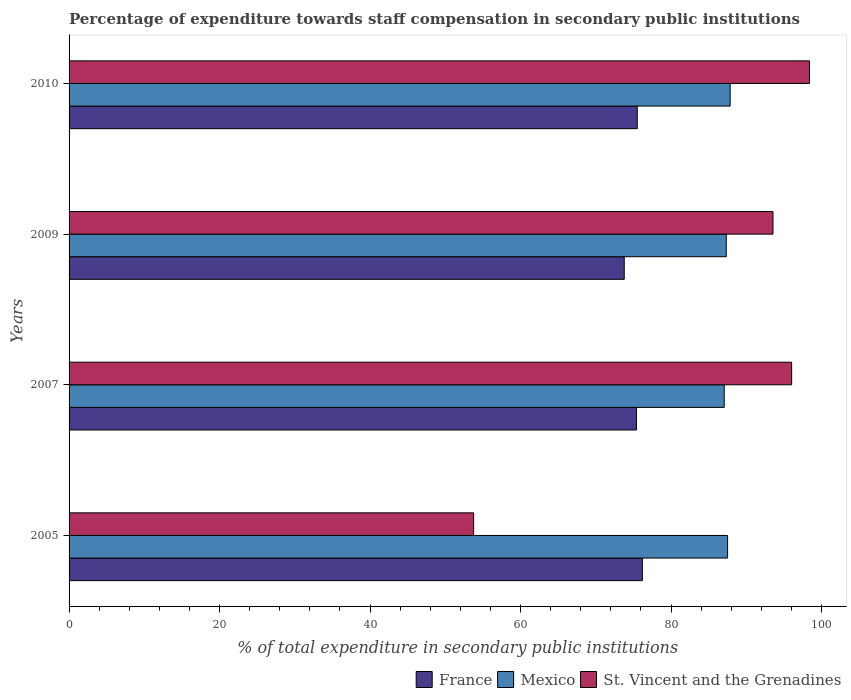How many different coloured bars are there?
Your response must be concise. 3. Are the number of bars per tick equal to the number of legend labels?
Offer a terse response. Yes. How many bars are there on the 1st tick from the top?
Make the answer very short. 3. What is the percentage of expenditure towards staff compensation in France in 2010?
Your answer should be compact. 75.51. Across all years, what is the maximum percentage of expenditure towards staff compensation in St. Vincent and the Grenadines?
Offer a terse response. 98.4. Across all years, what is the minimum percentage of expenditure towards staff compensation in France?
Your answer should be very brief. 73.78. In which year was the percentage of expenditure towards staff compensation in Mexico maximum?
Your response must be concise. 2010. In which year was the percentage of expenditure towards staff compensation in St. Vincent and the Grenadines minimum?
Offer a terse response. 2005. What is the total percentage of expenditure towards staff compensation in Mexico in the graph?
Your answer should be compact. 349.77. What is the difference between the percentage of expenditure towards staff compensation in St. Vincent and the Grenadines in 2009 and that in 2010?
Your answer should be compact. -4.85. What is the difference between the percentage of expenditure towards staff compensation in Mexico in 2009 and the percentage of expenditure towards staff compensation in France in 2007?
Offer a very short reply. 11.93. What is the average percentage of expenditure towards staff compensation in France per year?
Offer a very short reply. 75.22. In the year 2009, what is the difference between the percentage of expenditure towards staff compensation in St. Vincent and the Grenadines and percentage of expenditure towards staff compensation in France?
Your response must be concise. 19.77. In how many years, is the percentage of expenditure towards staff compensation in France greater than 44 %?
Offer a very short reply. 4. What is the ratio of the percentage of expenditure towards staff compensation in France in 2005 to that in 2010?
Make the answer very short. 1.01. Is the percentage of expenditure towards staff compensation in Mexico in 2007 less than that in 2009?
Your answer should be compact. Yes. Is the difference between the percentage of expenditure towards staff compensation in St. Vincent and the Grenadines in 2009 and 2010 greater than the difference between the percentage of expenditure towards staff compensation in France in 2009 and 2010?
Keep it short and to the point. No. What is the difference between the highest and the second highest percentage of expenditure towards staff compensation in France?
Provide a short and direct response. 0.68. What is the difference between the highest and the lowest percentage of expenditure towards staff compensation in France?
Ensure brevity in your answer.  2.41. In how many years, is the percentage of expenditure towards staff compensation in St. Vincent and the Grenadines greater than the average percentage of expenditure towards staff compensation in St. Vincent and the Grenadines taken over all years?
Provide a short and direct response. 3. Is the sum of the percentage of expenditure towards staff compensation in Mexico in 2007 and 2009 greater than the maximum percentage of expenditure towards staff compensation in France across all years?
Offer a terse response. Yes. What does the 2nd bar from the top in 2007 represents?
Make the answer very short. Mexico. What does the 3rd bar from the bottom in 2009 represents?
Make the answer very short. St. Vincent and the Grenadines. Is it the case that in every year, the sum of the percentage of expenditure towards staff compensation in Mexico and percentage of expenditure towards staff compensation in St. Vincent and the Grenadines is greater than the percentage of expenditure towards staff compensation in France?
Keep it short and to the point. Yes. How many years are there in the graph?
Your answer should be compact. 4. What is the difference between two consecutive major ticks on the X-axis?
Offer a terse response. 20. Does the graph contain any zero values?
Ensure brevity in your answer.  No. Does the graph contain grids?
Your answer should be compact. No. Where does the legend appear in the graph?
Your answer should be compact. Bottom right. How are the legend labels stacked?
Your response must be concise. Horizontal. What is the title of the graph?
Keep it short and to the point. Percentage of expenditure towards staff compensation in secondary public institutions. Does "World" appear as one of the legend labels in the graph?
Your answer should be compact. No. What is the label or title of the X-axis?
Your answer should be very brief. % of total expenditure in secondary public institutions. What is the label or title of the Y-axis?
Keep it short and to the point. Years. What is the % of total expenditure in secondary public institutions of France in 2005?
Offer a very short reply. 76.19. What is the % of total expenditure in secondary public institutions of Mexico in 2005?
Provide a short and direct response. 87.52. What is the % of total expenditure in secondary public institutions in St. Vincent and the Grenadines in 2005?
Make the answer very short. 53.76. What is the % of total expenditure in secondary public institutions of France in 2007?
Make the answer very short. 75.4. What is the % of total expenditure in secondary public institutions in Mexico in 2007?
Your answer should be compact. 87.07. What is the % of total expenditure in secondary public institutions in St. Vincent and the Grenadines in 2007?
Your answer should be compact. 96.03. What is the % of total expenditure in secondary public institutions in France in 2009?
Offer a very short reply. 73.78. What is the % of total expenditure in secondary public institutions of Mexico in 2009?
Provide a succinct answer. 87.34. What is the % of total expenditure in secondary public institutions of St. Vincent and the Grenadines in 2009?
Ensure brevity in your answer.  93.55. What is the % of total expenditure in secondary public institutions of France in 2010?
Offer a very short reply. 75.51. What is the % of total expenditure in secondary public institutions of Mexico in 2010?
Give a very brief answer. 87.85. What is the % of total expenditure in secondary public institutions in St. Vincent and the Grenadines in 2010?
Provide a succinct answer. 98.4. Across all years, what is the maximum % of total expenditure in secondary public institutions of France?
Ensure brevity in your answer.  76.19. Across all years, what is the maximum % of total expenditure in secondary public institutions of Mexico?
Make the answer very short. 87.85. Across all years, what is the maximum % of total expenditure in secondary public institutions in St. Vincent and the Grenadines?
Ensure brevity in your answer.  98.4. Across all years, what is the minimum % of total expenditure in secondary public institutions of France?
Ensure brevity in your answer.  73.78. Across all years, what is the minimum % of total expenditure in secondary public institutions of Mexico?
Provide a succinct answer. 87.07. Across all years, what is the minimum % of total expenditure in secondary public institutions in St. Vincent and the Grenadines?
Provide a short and direct response. 53.76. What is the total % of total expenditure in secondary public institutions of France in the graph?
Ensure brevity in your answer.  300.88. What is the total % of total expenditure in secondary public institutions in Mexico in the graph?
Offer a terse response. 349.77. What is the total % of total expenditure in secondary public institutions of St. Vincent and the Grenadines in the graph?
Your answer should be very brief. 341.74. What is the difference between the % of total expenditure in secondary public institutions of France in 2005 and that in 2007?
Your answer should be very brief. 0.78. What is the difference between the % of total expenditure in secondary public institutions in Mexico in 2005 and that in 2007?
Provide a short and direct response. 0.45. What is the difference between the % of total expenditure in secondary public institutions in St. Vincent and the Grenadines in 2005 and that in 2007?
Provide a succinct answer. -42.26. What is the difference between the % of total expenditure in secondary public institutions in France in 2005 and that in 2009?
Keep it short and to the point. 2.41. What is the difference between the % of total expenditure in secondary public institutions in Mexico in 2005 and that in 2009?
Provide a succinct answer. 0.18. What is the difference between the % of total expenditure in secondary public institutions in St. Vincent and the Grenadines in 2005 and that in 2009?
Provide a short and direct response. -39.78. What is the difference between the % of total expenditure in secondary public institutions of France in 2005 and that in 2010?
Your answer should be compact. 0.68. What is the difference between the % of total expenditure in secondary public institutions in Mexico in 2005 and that in 2010?
Keep it short and to the point. -0.34. What is the difference between the % of total expenditure in secondary public institutions of St. Vincent and the Grenadines in 2005 and that in 2010?
Offer a very short reply. -44.63. What is the difference between the % of total expenditure in secondary public institutions in France in 2007 and that in 2009?
Provide a succinct answer. 1.63. What is the difference between the % of total expenditure in secondary public institutions of Mexico in 2007 and that in 2009?
Provide a succinct answer. -0.27. What is the difference between the % of total expenditure in secondary public institutions of St. Vincent and the Grenadines in 2007 and that in 2009?
Your answer should be compact. 2.48. What is the difference between the % of total expenditure in secondary public institutions in France in 2007 and that in 2010?
Provide a succinct answer. -0.11. What is the difference between the % of total expenditure in secondary public institutions of Mexico in 2007 and that in 2010?
Keep it short and to the point. -0.79. What is the difference between the % of total expenditure in secondary public institutions of St. Vincent and the Grenadines in 2007 and that in 2010?
Make the answer very short. -2.37. What is the difference between the % of total expenditure in secondary public institutions in France in 2009 and that in 2010?
Give a very brief answer. -1.73. What is the difference between the % of total expenditure in secondary public institutions of Mexico in 2009 and that in 2010?
Make the answer very short. -0.52. What is the difference between the % of total expenditure in secondary public institutions of St. Vincent and the Grenadines in 2009 and that in 2010?
Your response must be concise. -4.85. What is the difference between the % of total expenditure in secondary public institutions in France in 2005 and the % of total expenditure in secondary public institutions in Mexico in 2007?
Your answer should be very brief. -10.88. What is the difference between the % of total expenditure in secondary public institutions in France in 2005 and the % of total expenditure in secondary public institutions in St. Vincent and the Grenadines in 2007?
Ensure brevity in your answer.  -19.84. What is the difference between the % of total expenditure in secondary public institutions of Mexico in 2005 and the % of total expenditure in secondary public institutions of St. Vincent and the Grenadines in 2007?
Offer a terse response. -8.51. What is the difference between the % of total expenditure in secondary public institutions of France in 2005 and the % of total expenditure in secondary public institutions of Mexico in 2009?
Your answer should be compact. -11.15. What is the difference between the % of total expenditure in secondary public institutions in France in 2005 and the % of total expenditure in secondary public institutions in St. Vincent and the Grenadines in 2009?
Your response must be concise. -17.36. What is the difference between the % of total expenditure in secondary public institutions of Mexico in 2005 and the % of total expenditure in secondary public institutions of St. Vincent and the Grenadines in 2009?
Your response must be concise. -6.03. What is the difference between the % of total expenditure in secondary public institutions of France in 2005 and the % of total expenditure in secondary public institutions of Mexico in 2010?
Give a very brief answer. -11.66. What is the difference between the % of total expenditure in secondary public institutions in France in 2005 and the % of total expenditure in secondary public institutions in St. Vincent and the Grenadines in 2010?
Give a very brief answer. -22.21. What is the difference between the % of total expenditure in secondary public institutions in Mexico in 2005 and the % of total expenditure in secondary public institutions in St. Vincent and the Grenadines in 2010?
Ensure brevity in your answer.  -10.88. What is the difference between the % of total expenditure in secondary public institutions of France in 2007 and the % of total expenditure in secondary public institutions of Mexico in 2009?
Ensure brevity in your answer.  -11.93. What is the difference between the % of total expenditure in secondary public institutions of France in 2007 and the % of total expenditure in secondary public institutions of St. Vincent and the Grenadines in 2009?
Your answer should be very brief. -18.14. What is the difference between the % of total expenditure in secondary public institutions in Mexico in 2007 and the % of total expenditure in secondary public institutions in St. Vincent and the Grenadines in 2009?
Give a very brief answer. -6.48. What is the difference between the % of total expenditure in secondary public institutions of France in 2007 and the % of total expenditure in secondary public institutions of Mexico in 2010?
Provide a succinct answer. -12.45. What is the difference between the % of total expenditure in secondary public institutions of France in 2007 and the % of total expenditure in secondary public institutions of St. Vincent and the Grenadines in 2010?
Ensure brevity in your answer.  -22.99. What is the difference between the % of total expenditure in secondary public institutions of Mexico in 2007 and the % of total expenditure in secondary public institutions of St. Vincent and the Grenadines in 2010?
Ensure brevity in your answer.  -11.33. What is the difference between the % of total expenditure in secondary public institutions of France in 2009 and the % of total expenditure in secondary public institutions of Mexico in 2010?
Give a very brief answer. -14.07. What is the difference between the % of total expenditure in secondary public institutions in France in 2009 and the % of total expenditure in secondary public institutions in St. Vincent and the Grenadines in 2010?
Make the answer very short. -24.62. What is the difference between the % of total expenditure in secondary public institutions of Mexico in 2009 and the % of total expenditure in secondary public institutions of St. Vincent and the Grenadines in 2010?
Your answer should be compact. -11.06. What is the average % of total expenditure in secondary public institutions of France per year?
Provide a succinct answer. 75.22. What is the average % of total expenditure in secondary public institutions of Mexico per year?
Ensure brevity in your answer.  87.44. What is the average % of total expenditure in secondary public institutions of St. Vincent and the Grenadines per year?
Your answer should be very brief. 85.43. In the year 2005, what is the difference between the % of total expenditure in secondary public institutions of France and % of total expenditure in secondary public institutions of Mexico?
Your answer should be compact. -11.33. In the year 2005, what is the difference between the % of total expenditure in secondary public institutions in France and % of total expenditure in secondary public institutions in St. Vincent and the Grenadines?
Give a very brief answer. 22.43. In the year 2005, what is the difference between the % of total expenditure in secondary public institutions of Mexico and % of total expenditure in secondary public institutions of St. Vincent and the Grenadines?
Ensure brevity in your answer.  33.75. In the year 2007, what is the difference between the % of total expenditure in secondary public institutions in France and % of total expenditure in secondary public institutions in Mexico?
Offer a terse response. -11.66. In the year 2007, what is the difference between the % of total expenditure in secondary public institutions of France and % of total expenditure in secondary public institutions of St. Vincent and the Grenadines?
Your answer should be compact. -20.62. In the year 2007, what is the difference between the % of total expenditure in secondary public institutions in Mexico and % of total expenditure in secondary public institutions in St. Vincent and the Grenadines?
Your answer should be very brief. -8.96. In the year 2009, what is the difference between the % of total expenditure in secondary public institutions of France and % of total expenditure in secondary public institutions of Mexico?
Make the answer very short. -13.56. In the year 2009, what is the difference between the % of total expenditure in secondary public institutions in France and % of total expenditure in secondary public institutions in St. Vincent and the Grenadines?
Provide a succinct answer. -19.77. In the year 2009, what is the difference between the % of total expenditure in secondary public institutions of Mexico and % of total expenditure in secondary public institutions of St. Vincent and the Grenadines?
Provide a succinct answer. -6.21. In the year 2010, what is the difference between the % of total expenditure in secondary public institutions in France and % of total expenditure in secondary public institutions in Mexico?
Your answer should be compact. -12.34. In the year 2010, what is the difference between the % of total expenditure in secondary public institutions in France and % of total expenditure in secondary public institutions in St. Vincent and the Grenadines?
Give a very brief answer. -22.89. In the year 2010, what is the difference between the % of total expenditure in secondary public institutions of Mexico and % of total expenditure in secondary public institutions of St. Vincent and the Grenadines?
Provide a succinct answer. -10.54. What is the ratio of the % of total expenditure in secondary public institutions in France in 2005 to that in 2007?
Ensure brevity in your answer.  1.01. What is the ratio of the % of total expenditure in secondary public institutions in St. Vincent and the Grenadines in 2005 to that in 2007?
Your answer should be very brief. 0.56. What is the ratio of the % of total expenditure in secondary public institutions of France in 2005 to that in 2009?
Provide a short and direct response. 1.03. What is the ratio of the % of total expenditure in secondary public institutions of St. Vincent and the Grenadines in 2005 to that in 2009?
Your response must be concise. 0.57. What is the ratio of the % of total expenditure in secondary public institutions in France in 2005 to that in 2010?
Your answer should be very brief. 1.01. What is the ratio of the % of total expenditure in secondary public institutions of St. Vincent and the Grenadines in 2005 to that in 2010?
Offer a very short reply. 0.55. What is the ratio of the % of total expenditure in secondary public institutions in France in 2007 to that in 2009?
Give a very brief answer. 1.02. What is the ratio of the % of total expenditure in secondary public institutions of Mexico in 2007 to that in 2009?
Your answer should be compact. 1. What is the ratio of the % of total expenditure in secondary public institutions in St. Vincent and the Grenadines in 2007 to that in 2009?
Your answer should be compact. 1.03. What is the ratio of the % of total expenditure in secondary public institutions in Mexico in 2007 to that in 2010?
Your answer should be very brief. 0.99. What is the ratio of the % of total expenditure in secondary public institutions of St. Vincent and the Grenadines in 2007 to that in 2010?
Make the answer very short. 0.98. What is the ratio of the % of total expenditure in secondary public institutions in France in 2009 to that in 2010?
Keep it short and to the point. 0.98. What is the ratio of the % of total expenditure in secondary public institutions in Mexico in 2009 to that in 2010?
Provide a succinct answer. 0.99. What is the ratio of the % of total expenditure in secondary public institutions of St. Vincent and the Grenadines in 2009 to that in 2010?
Provide a succinct answer. 0.95. What is the difference between the highest and the second highest % of total expenditure in secondary public institutions of France?
Ensure brevity in your answer.  0.68. What is the difference between the highest and the second highest % of total expenditure in secondary public institutions of Mexico?
Ensure brevity in your answer.  0.34. What is the difference between the highest and the second highest % of total expenditure in secondary public institutions of St. Vincent and the Grenadines?
Offer a very short reply. 2.37. What is the difference between the highest and the lowest % of total expenditure in secondary public institutions in France?
Your answer should be very brief. 2.41. What is the difference between the highest and the lowest % of total expenditure in secondary public institutions in Mexico?
Ensure brevity in your answer.  0.79. What is the difference between the highest and the lowest % of total expenditure in secondary public institutions in St. Vincent and the Grenadines?
Provide a short and direct response. 44.63. 